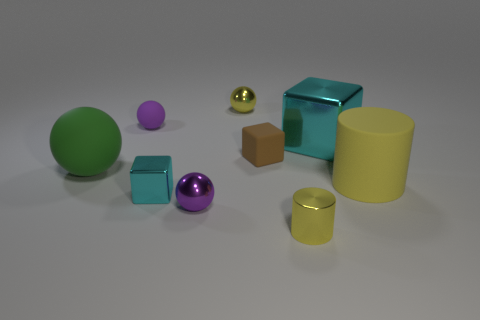There is a ball that is in front of the large thing that is left of the big thing behind the brown cube; what is its material?
Your answer should be compact. Metal. What number of cylinders are either blue matte things or large yellow matte objects?
Your answer should be compact. 1. What number of shiny cubes are on the right side of the cyan shiny cube in front of the rubber thing that is to the right of the matte cube?
Keep it short and to the point. 1. Is the green thing the same shape as the small cyan object?
Ensure brevity in your answer.  No. Is the small yellow thing that is behind the big green rubber ball made of the same material as the cyan thing right of the small yellow metal cylinder?
Your answer should be very brief. Yes. How many things are either small purple objects that are behind the green ball or small purple objects on the left side of the tiny cyan metallic block?
Your answer should be compact. 1. How many small yellow metal balls are there?
Offer a terse response. 1. Are there any metal objects that have the same size as the brown matte object?
Your answer should be compact. Yes. Do the tiny yellow cylinder and the thing that is left of the purple matte thing have the same material?
Provide a succinct answer. No. What is the material of the cylinder behind the small purple metallic thing?
Provide a short and direct response. Rubber. 